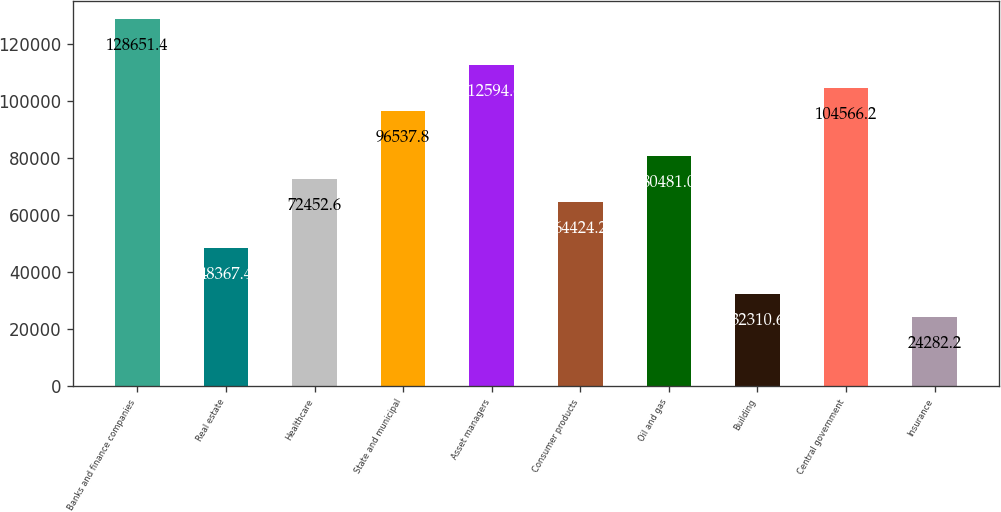Convert chart to OTSL. <chart><loc_0><loc_0><loc_500><loc_500><bar_chart><fcel>Banks and finance companies<fcel>Real estate<fcel>Healthcare<fcel>State and municipal<fcel>Asset managers<fcel>Consumer products<fcel>Oil and gas<fcel>Building<fcel>Central government<fcel>Insurance<nl><fcel>128651<fcel>48367.4<fcel>72452.6<fcel>96537.8<fcel>112595<fcel>64424.2<fcel>80481<fcel>32310.6<fcel>104566<fcel>24282.2<nl></chart> 